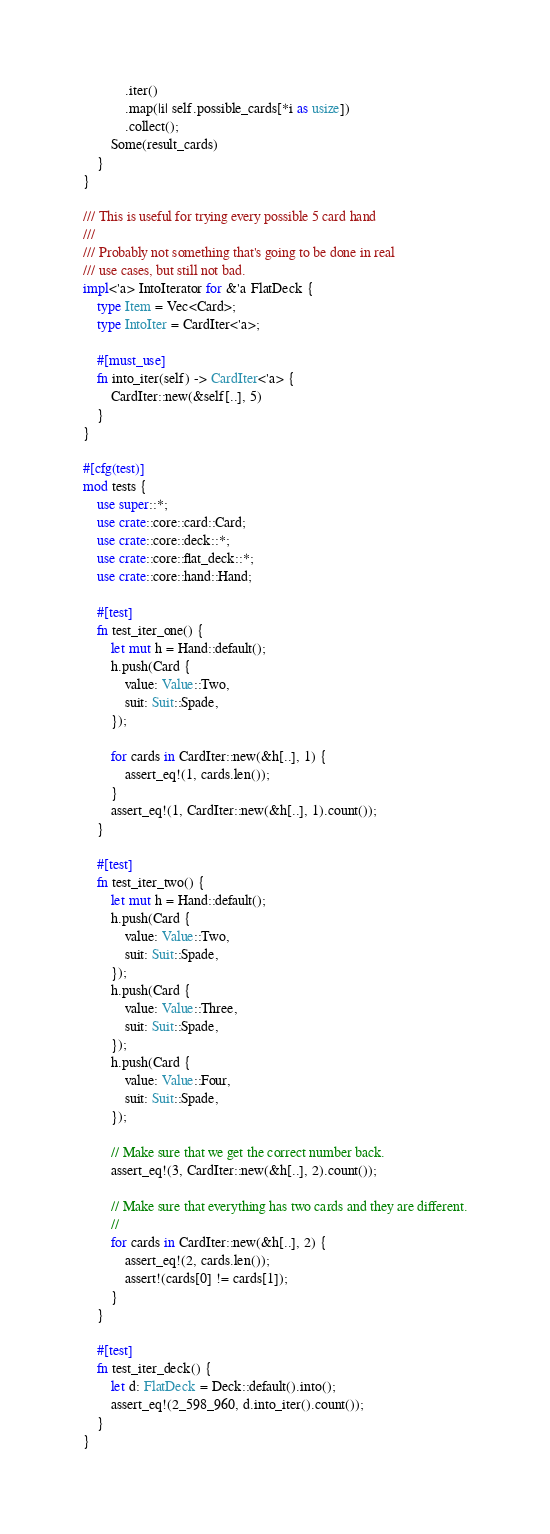<code> <loc_0><loc_0><loc_500><loc_500><_Rust_>            .iter()
            .map(|i| self.possible_cards[*i as usize])
            .collect();
        Some(result_cards)
    }
}

/// This is useful for trying every possible 5 card hand
///
/// Probably not something that's going to be done in real
/// use cases, but still not bad.
impl<'a> IntoIterator for &'a FlatDeck {
    type Item = Vec<Card>;
    type IntoIter = CardIter<'a>;

    #[must_use]
    fn into_iter(self) -> CardIter<'a> {
        CardIter::new(&self[..], 5)
    }
}

#[cfg(test)]
mod tests {
    use super::*;
    use crate::core::card::Card;
    use crate::core::deck::*;
    use crate::core::flat_deck::*;
    use crate::core::hand::Hand;

    #[test]
    fn test_iter_one() {
        let mut h = Hand::default();
        h.push(Card {
            value: Value::Two,
            suit: Suit::Spade,
        });

        for cards in CardIter::new(&h[..], 1) {
            assert_eq!(1, cards.len());
        }
        assert_eq!(1, CardIter::new(&h[..], 1).count());
    }

    #[test]
    fn test_iter_two() {
        let mut h = Hand::default();
        h.push(Card {
            value: Value::Two,
            suit: Suit::Spade,
        });
        h.push(Card {
            value: Value::Three,
            suit: Suit::Spade,
        });
        h.push(Card {
            value: Value::Four,
            suit: Suit::Spade,
        });

        // Make sure that we get the correct number back.
        assert_eq!(3, CardIter::new(&h[..], 2).count());

        // Make sure that everything has two cards and they are different.
        //
        for cards in CardIter::new(&h[..], 2) {
            assert_eq!(2, cards.len());
            assert!(cards[0] != cards[1]);
        }
    }

    #[test]
    fn test_iter_deck() {
        let d: FlatDeck = Deck::default().into();
        assert_eq!(2_598_960, d.into_iter().count());
    }
}
</code> 